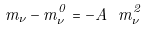<formula> <loc_0><loc_0><loc_500><loc_500>m _ { \nu } - m ^ { 0 } _ { \nu } = - A \ m ^ { 2 } _ { \nu }</formula> 